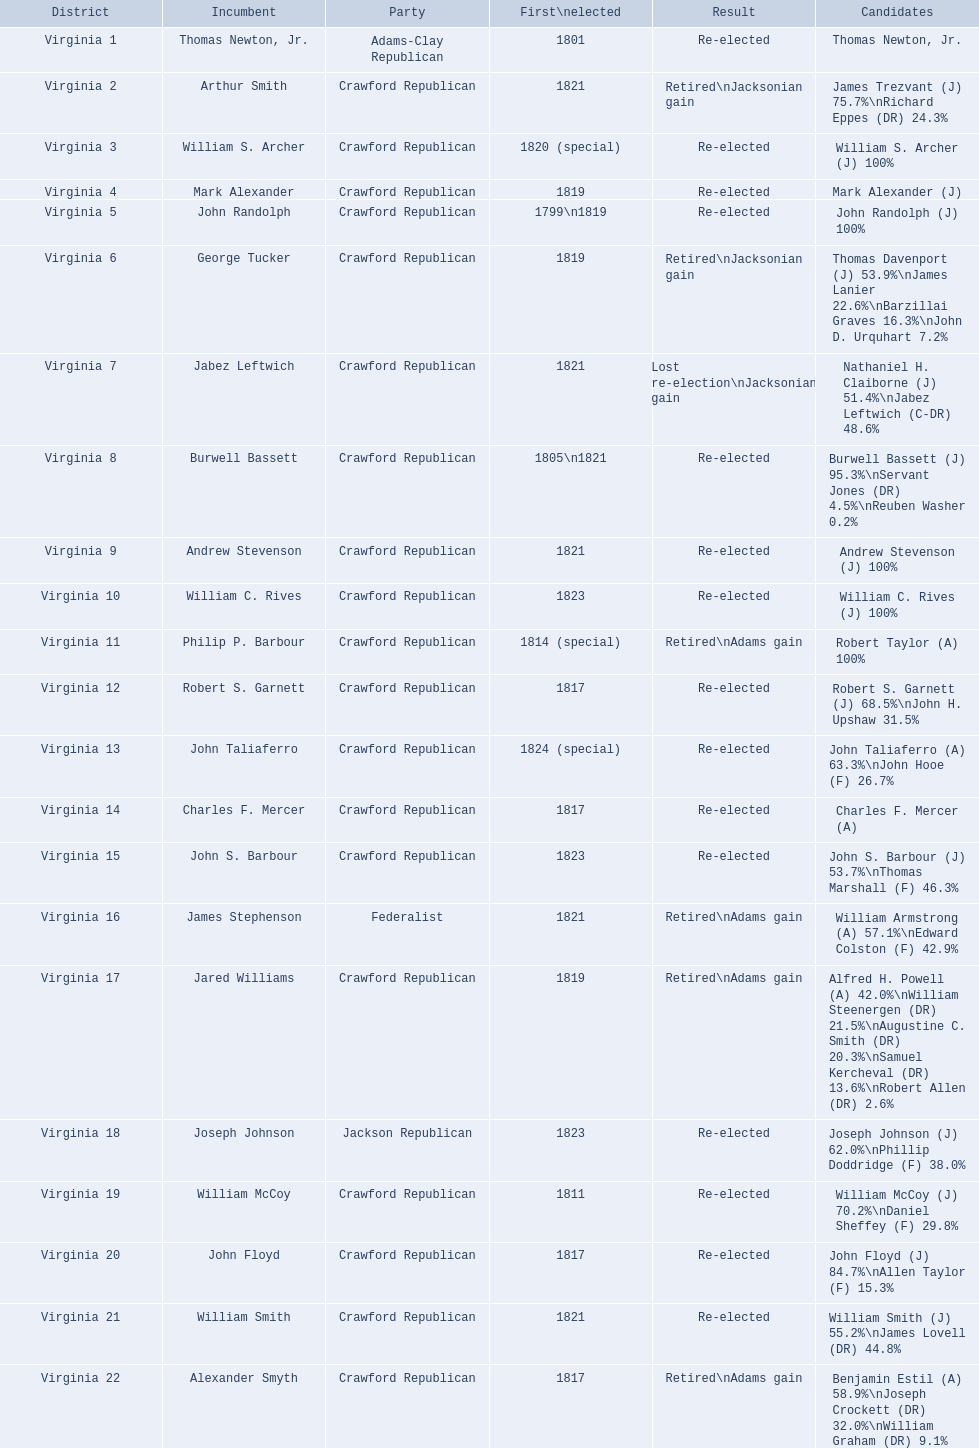Which incumbents belonged to the crawford republican party? Arthur Smith, William S. Archer, Mark Alexander, John Randolph, George Tucker, Jabez Leftwich, Burwell Bassett, Andrew Stevenson, William C. Rives, Philip P. Barbour, Robert S. Garnett, John Taliaferro, Charles F. Mercer, John S. Barbour, Jared Williams, William McCoy, John Floyd, William Smith, Alexander Smyth. Which of these incumbents were first elected in 1821? Arthur Smith, Jabez Leftwich, Andrew Stevenson, William Smith. Which of these incumbents have a last name of smith? Arthur Smith, William Smith. Which of these two were not re-elected? Arthur Smith. 